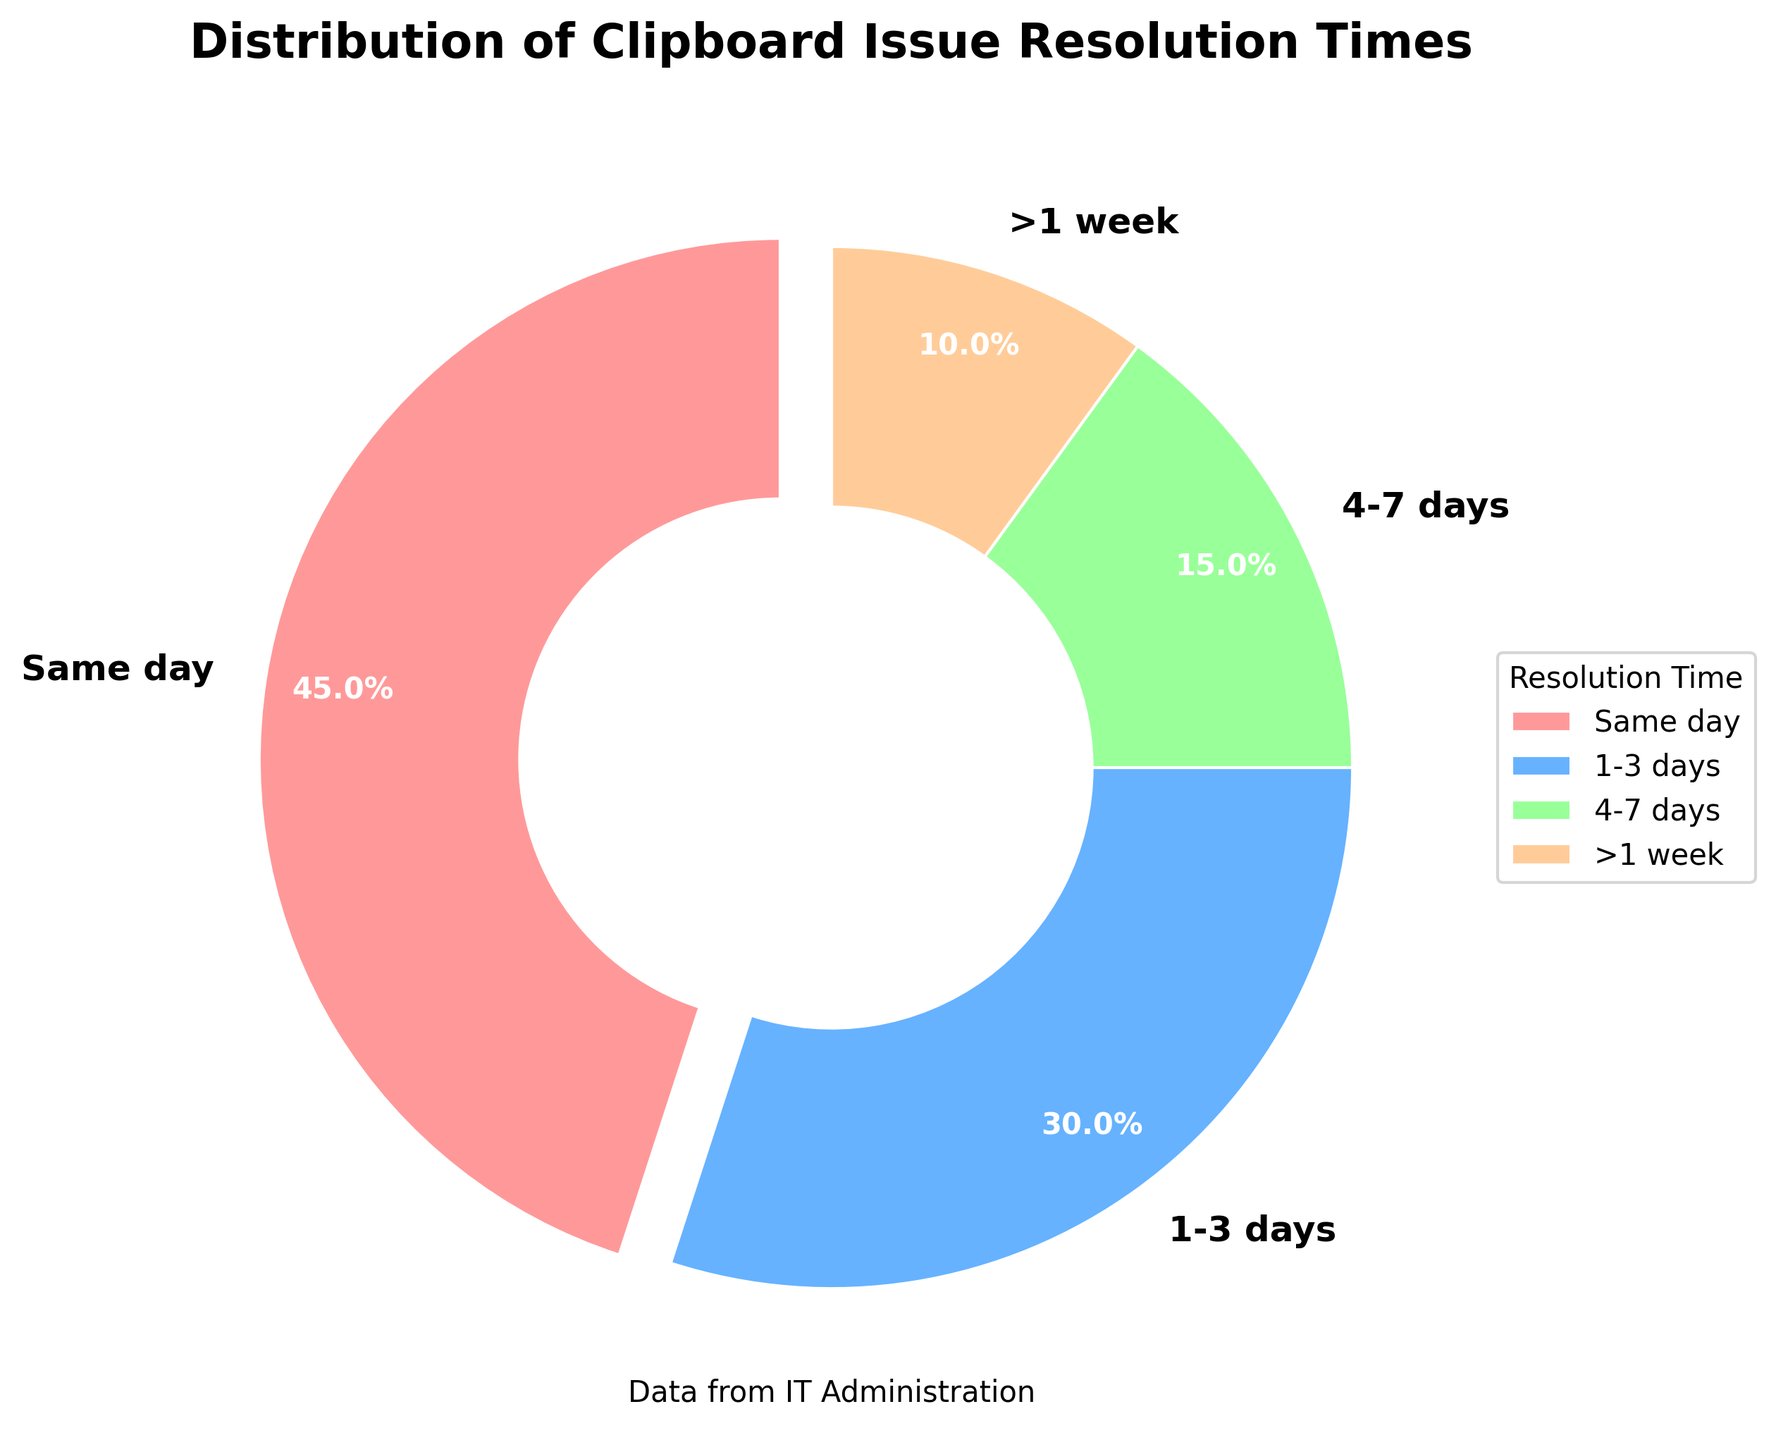Which resolution time has the highest percentage? The slice representing 'Same day' is the largest in the pie chart and has a label indicating 45%. Hence, the resolution time with the highest percentage is 'Same day'.
Answer: Same day What is the combined percentage of issues resolved within a week? To find the combined percentage of issues resolved within a week, sum the percentages of 'Same day', '1-3 days', and '4-7 days'. This yields 45% + 30% + 15% = 90%.
Answer: 90% Which category takes the longest time for issue resolution? The '>' symbol in '>1 week' indicates this category represents the longest time among the listed resolution times. Additionally, the chart indicates it has a 10% slice.
Answer: >1 week Compare the proportion of issues resolved on the same day and those taking more than a week. Which is higher, and by how much? By comparing the 'Same day' (45%) and '>1 week' (10%) categories, the 'Same day' category is higher. The difference in percentages is 45% - 10% = 35%.
Answer: Same day by 35% How does the proportion of issues resolved in 1-3 days compare to those resolved in 4-7 days? The '1-3 days' slice is labeled as 30%, while the '4-7 days' slice is labeled as 15%. Therefore, the proportion of issues resolved in '1-3 days' is higher than those resolved in '4-7 days'.
Answer: 1-3 days Calculate the total percentage of issues taking longer than 3 days to resolve. This requires adding the percentages of '4-7 days' and '>1 week'. Thus, 15% (4-7 days) + 10% (>1 week) = 25%.
Answer: 25% Which resolution time is associated with the lightest-colored segment? The 'Same day' segment is the lightest-colored, presumably represented by a lighter color among the provided options (e.g., light red).
Answer: Same day What is the color associated with the '1-3 days' resolution time? By visually inspecting the pie chart, it's observed that the '1-3 days' segment is shaded with a blue color.
Answer: Blue Estimate the difference between the percentages of the '1-3 days' and '>1 week' resolution times. The percentage for '1-3 days' is 30%, and that for '>1 week' is 10%. Therefore, the difference is 30% - 10% = 20%.
Answer: 20% If we combine the percentages of '4-7 days' and '>1 week', does this total exceed the percentage of '1-3 days'? Summing '4-7 days' (15%) and '>1 week' (10%) results in 25%. This total is less than the '1-3 days' percentage of 30%.
Answer: No 